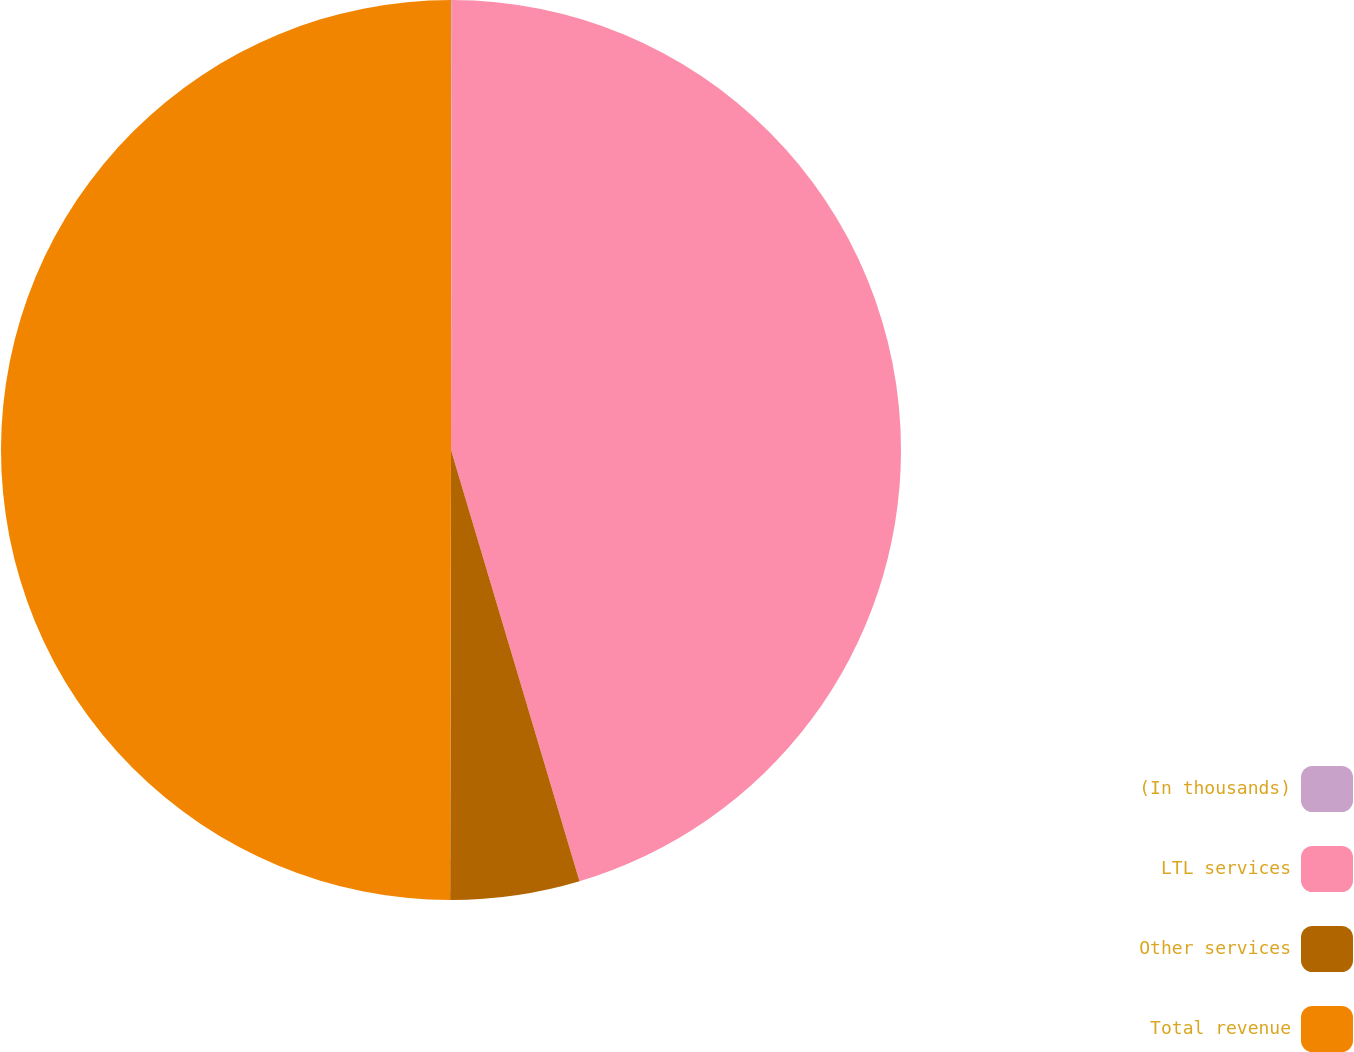<chart> <loc_0><loc_0><loc_500><loc_500><pie_chart><fcel>(In thousands)<fcel>LTL services<fcel>Other services<fcel>Total revenue<nl><fcel>0.03%<fcel>45.36%<fcel>4.64%<fcel>49.97%<nl></chart> 